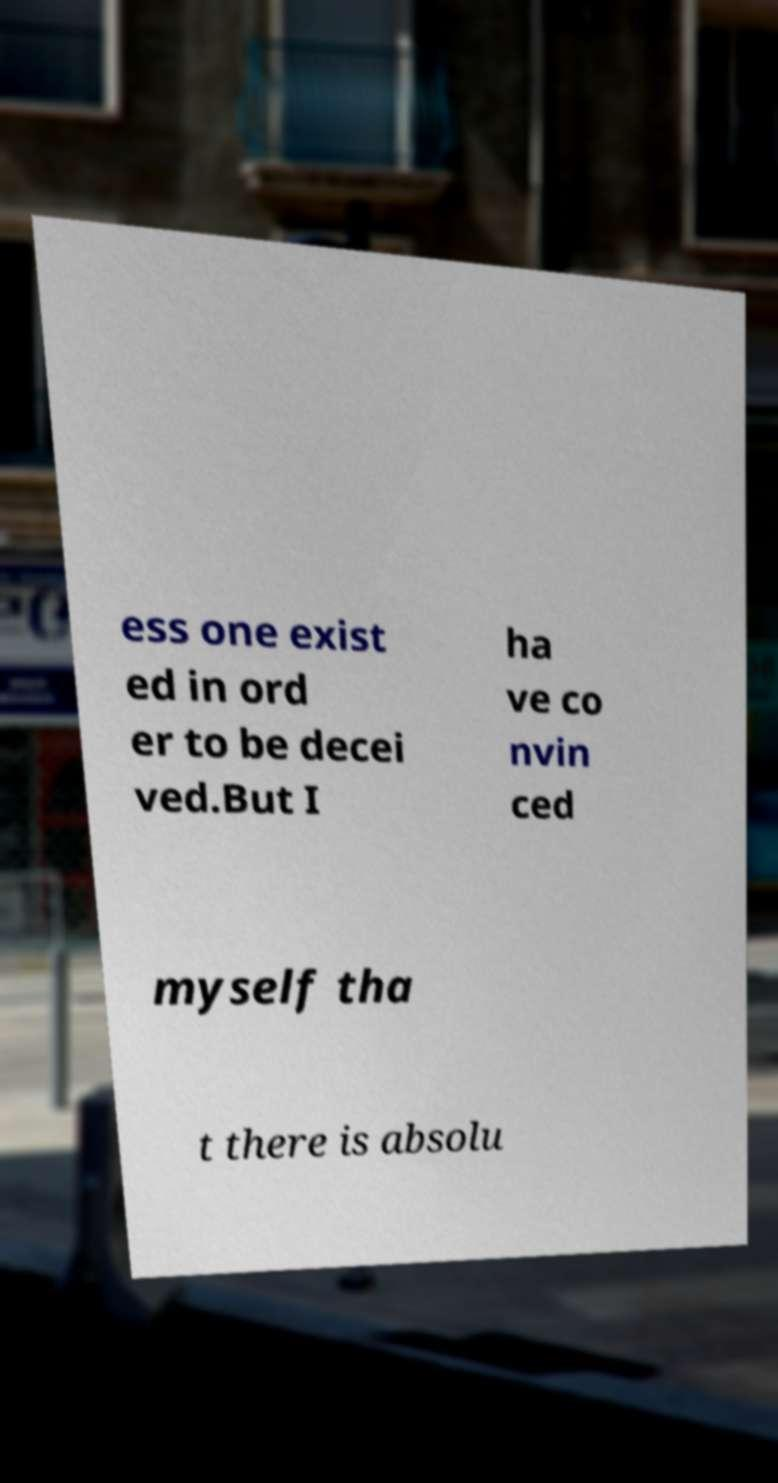Could you extract and type out the text from this image? ess one exist ed in ord er to be decei ved.But I ha ve co nvin ced myself tha t there is absolu 